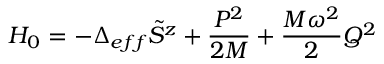<formula> <loc_0><loc_0><loc_500><loc_500>H _ { 0 } = - \Delta _ { e f f } \tilde { S } ^ { z } + \frac { P ^ { 2 } } { 2 M } + \frac { M \omega ^ { 2 } } { 2 } Q ^ { 2 }</formula> 